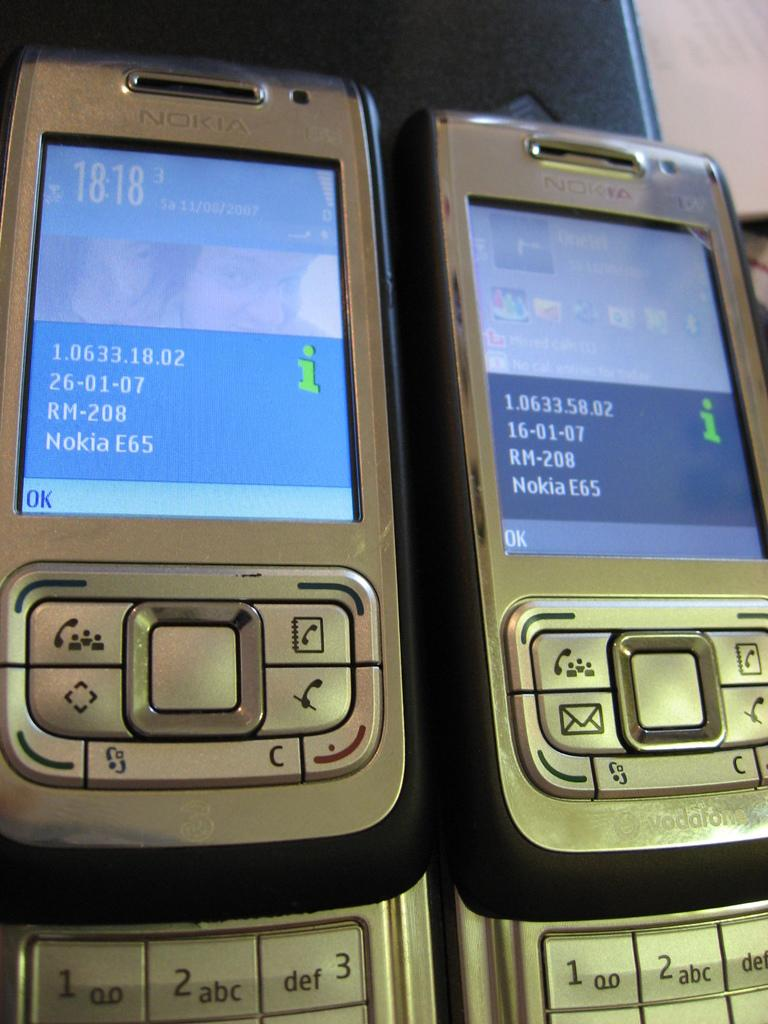<image>
Share a concise interpretation of the image provided. Two Nokia phones are next to one another. 